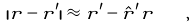Convert formula to latex. <formula><loc_0><loc_0><loc_500><loc_500>| { r } - { r ^ { \prime } } | \approx r ^ { \prime } - \hat { r } ^ { \prime } { r } \quad ,</formula> 